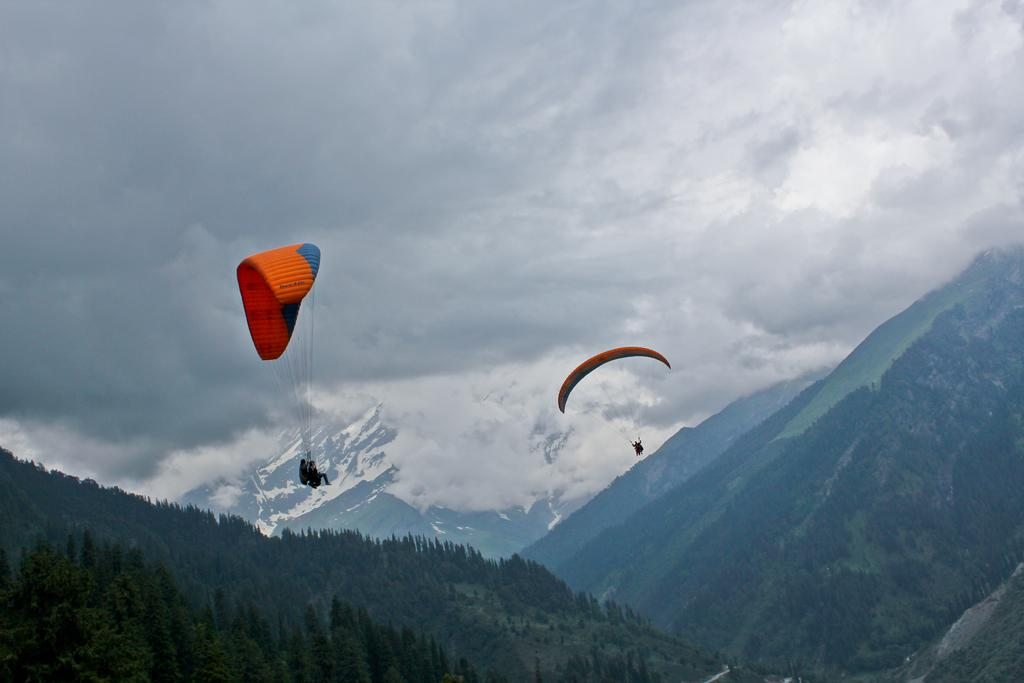What is the main subject in the center of the image? There are parachutes in the center of the image. What are the persons in the image doing? The persons are flying in the air. What type of landscape can be seen in the background of the image? Hills, trees, mountains, snow, and the sky are visible in the background of the image. What weather condition can be inferred from the presence of clouds in the image? The presence of clouds suggests that the weather might be partly cloudy. Can you tell me how many oranges are present in the image? There are no oranges present in the image. What type of cave can be seen in the background of the image? There is no cave present in the image; it features parachutes, persons flying, and a landscape with hills, trees, mountains, snow, and the sky. 